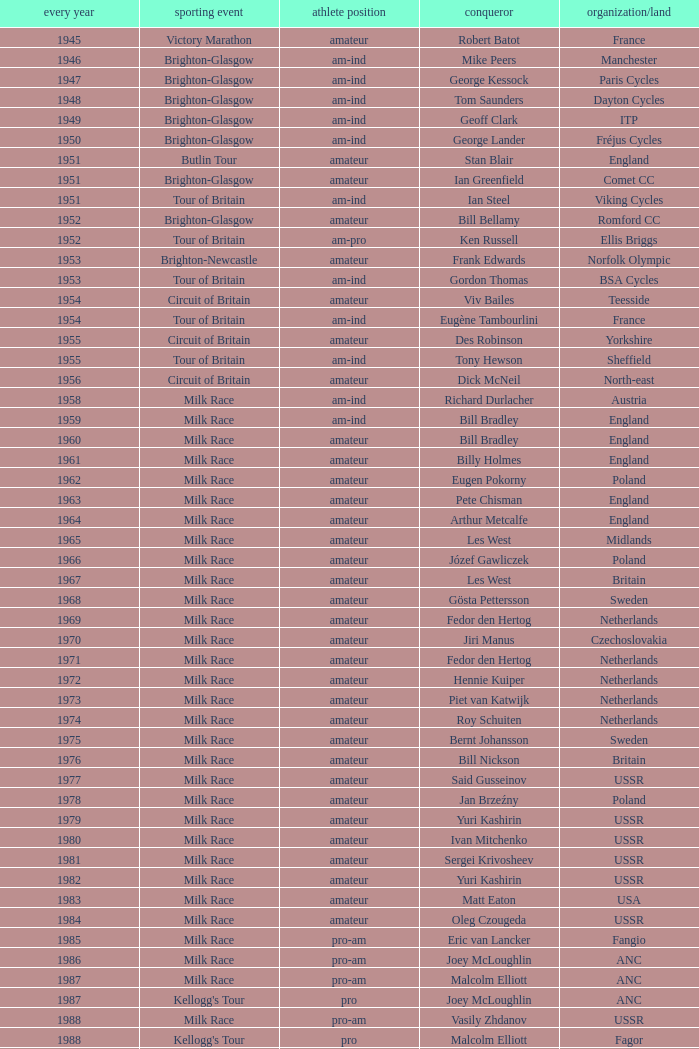What is the latest year when Phil Anderson won? 1993.0. 